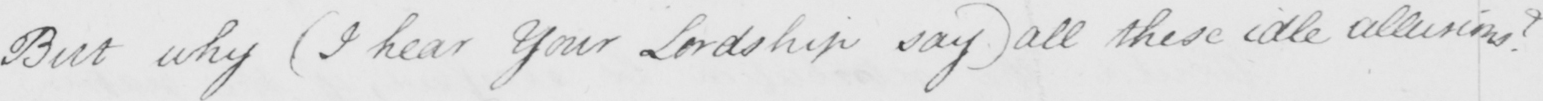Transcribe the text shown in this historical manuscript line. But why  ( I hear Your Lordship say )  all these idle allusions ? 